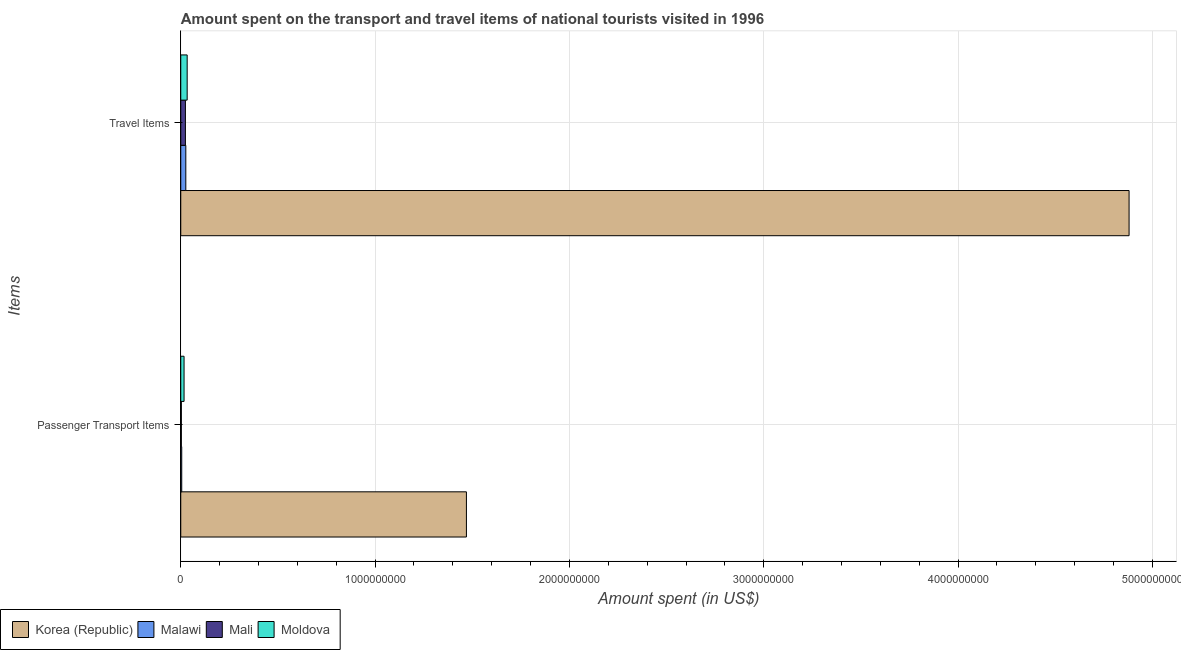How many different coloured bars are there?
Keep it short and to the point. 4. How many bars are there on the 2nd tick from the bottom?
Provide a succinct answer. 4. What is the label of the 1st group of bars from the top?
Provide a succinct answer. Travel Items. What is the amount spent in travel items in Mali?
Offer a terse response. 2.40e+07. Across all countries, what is the maximum amount spent on passenger transport items?
Give a very brief answer. 1.47e+09. Across all countries, what is the minimum amount spent on passenger transport items?
Your response must be concise. 3.00e+06. In which country was the amount spent on passenger transport items maximum?
Provide a succinct answer. Korea (Republic). In which country was the amount spent on passenger transport items minimum?
Ensure brevity in your answer.  Mali. What is the total amount spent on passenger transport items in the graph?
Keep it short and to the point. 1.50e+09. What is the difference between the amount spent on passenger transport items in Korea (Republic) and that in Moldova?
Your answer should be very brief. 1.45e+09. What is the difference between the amount spent in travel items in Mali and the amount spent on passenger transport items in Moldova?
Your answer should be compact. 7.00e+06. What is the average amount spent in travel items per country?
Give a very brief answer. 1.24e+09. What is the difference between the amount spent on passenger transport items and amount spent in travel items in Malawi?
Offer a very short reply. -2.10e+07. What is the ratio of the amount spent on passenger transport items in Moldova to that in Korea (Republic)?
Your answer should be compact. 0.01. What does the 3rd bar from the top in Travel Items represents?
Keep it short and to the point. Malawi. How many bars are there?
Provide a succinct answer. 8. Are all the bars in the graph horizontal?
Give a very brief answer. Yes. What is the difference between two consecutive major ticks on the X-axis?
Your response must be concise. 1.00e+09. Are the values on the major ticks of X-axis written in scientific E-notation?
Your response must be concise. No. Does the graph contain any zero values?
Give a very brief answer. No. Does the graph contain grids?
Ensure brevity in your answer.  Yes. How many legend labels are there?
Provide a short and direct response. 4. What is the title of the graph?
Your answer should be very brief. Amount spent on the transport and travel items of national tourists visited in 1996. What is the label or title of the X-axis?
Your response must be concise. Amount spent (in US$). What is the label or title of the Y-axis?
Your answer should be very brief. Items. What is the Amount spent (in US$) of Korea (Republic) in Passenger Transport Items?
Offer a very short reply. 1.47e+09. What is the Amount spent (in US$) of Malawi in Passenger Transport Items?
Provide a succinct answer. 5.00e+06. What is the Amount spent (in US$) of Moldova in Passenger Transport Items?
Provide a succinct answer. 1.70e+07. What is the Amount spent (in US$) in Korea (Republic) in Travel Items?
Keep it short and to the point. 4.88e+09. What is the Amount spent (in US$) of Malawi in Travel Items?
Make the answer very short. 2.60e+07. What is the Amount spent (in US$) of Mali in Travel Items?
Offer a very short reply. 2.40e+07. What is the Amount spent (in US$) in Moldova in Travel Items?
Your answer should be compact. 3.30e+07. Across all Items, what is the maximum Amount spent (in US$) of Korea (Republic)?
Offer a very short reply. 4.88e+09. Across all Items, what is the maximum Amount spent (in US$) in Malawi?
Offer a terse response. 2.60e+07. Across all Items, what is the maximum Amount spent (in US$) in Mali?
Keep it short and to the point. 2.40e+07. Across all Items, what is the maximum Amount spent (in US$) in Moldova?
Offer a terse response. 3.30e+07. Across all Items, what is the minimum Amount spent (in US$) in Korea (Republic)?
Keep it short and to the point. 1.47e+09. Across all Items, what is the minimum Amount spent (in US$) in Moldova?
Offer a terse response. 1.70e+07. What is the total Amount spent (in US$) in Korea (Republic) in the graph?
Your answer should be compact. 6.35e+09. What is the total Amount spent (in US$) of Malawi in the graph?
Give a very brief answer. 3.10e+07. What is the total Amount spent (in US$) of Mali in the graph?
Give a very brief answer. 2.70e+07. What is the total Amount spent (in US$) of Moldova in the graph?
Your answer should be compact. 5.00e+07. What is the difference between the Amount spent (in US$) of Korea (Republic) in Passenger Transport Items and that in Travel Items?
Your answer should be compact. -3.41e+09. What is the difference between the Amount spent (in US$) of Malawi in Passenger Transport Items and that in Travel Items?
Ensure brevity in your answer.  -2.10e+07. What is the difference between the Amount spent (in US$) in Mali in Passenger Transport Items and that in Travel Items?
Give a very brief answer. -2.10e+07. What is the difference between the Amount spent (in US$) of Moldova in Passenger Transport Items and that in Travel Items?
Offer a terse response. -1.60e+07. What is the difference between the Amount spent (in US$) in Korea (Republic) in Passenger Transport Items and the Amount spent (in US$) in Malawi in Travel Items?
Ensure brevity in your answer.  1.44e+09. What is the difference between the Amount spent (in US$) of Korea (Republic) in Passenger Transport Items and the Amount spent (in US$) of Mali in Travel Items?
Make the answer very short. 1.45e+09. What is the difference between the Amount spent (in US$) of Korea (Republic) in Passenger Transport Items and the Amount spent (in US$) of Moldova in Travel Items?
Make the answer very short. 1.44e+09. What is the difference between the Amount spent (in US$) of Malawi in Passenger Transport Items and the Amount spent (in US$) of Mali in Travel Items?
Your answer should be compact. -1.90e+07. What is the difference between the Amount spent (in US$) in Malawi in Passenger Transport Items and the Amount spent (in US$) in Moldova in Travel Items?
Give a very brief answer. -2.80e+07. What is the difference between the Amount spent (in US$) in Mali in Passenger Transport Items and the Amount spent (in US$) in Moldova in Travel Items?
Your response must be concise. -3.00e+07. What is the average Amount spent (in US$) in Korea (Republic) per Items?
Provide a short and direct response. 3.18e+09. What is the average Amount spent (in US$) in Malawi per Items?
Offer a very short reply. 1.55e+07. What is the average Amount spent (in US$) in Mali per Items?
Your response must be concise. 1.35e+07. What is the average Amount spent (in US$) of Moldova per Items?
Your response must be concise. 2.50e+07. What is the difference between the Amount spent (in US$) of Korea (Republic) and Amount spent (in US$) of Malawi in Passenger Transport Items?
Provide a short and direct response. 1.46e+09. What is the difference between the Amount spent (in US$) of Korea (Republic) and Amount spent (in US$) of Mali in Passenger Transport Items?
Make the answer very short. 1.47e+09. What is the difference between the Amount spent (in US$) of Korea (Republic) and Amount spent (in US$) of Moldova in Passenger Transport Items?
Offer a terse response. 1.45e+09. What is the difference between the Amount spent (in US$) of Malawi and Amount spent (in US$) of Moldova in Passenger Transport Items?
Ensure brevity in your answer.  -1.20e+07. What is the difference between the Amount spent (in US$) of Mali and Amount spent (in US$) of Moldova in Passenger Transport Items?
Your response must be concise. -1.40e+07. What is the difference between the Amount spent (in US$) in Korea (Republic) and Amount spent (in US$) in Malawi in Travel Items?
Give a very brief answer. 4.85e+09. What is the difference between the Amount spent (in US$) in Korea (Republic) and Amount spent (in US$) in Mali in Travel Items?
Give a very brief answer. 4.86e+09. What is the difference between the Amount spent (in US$) of Korea (Republic) and Amount spent (in US$) of Moldova in Travel Items?
Ensure brevity in your answer.  4.85e+09. What is the difference between the Amount spent (in US$) of Malawi and Amount spent (in US$) of Moldova in Travel Items?
Provide a succinct answer. -7.00e+06. What is the difference between the Amount spent (in US$) in Mali and Amount spent (in US$) in Moldova in Travel Items?
Provide a succinct answer. -9.00e+06. What is the ratio of the Amount spent (in US$) in Korea (Republic) in Passenger Transport Items to that in Travel Items?
Your response must be concise. 0.3. What is the ratio of the Amount spent (in US$) of Malawi in Passenger Transport Items to that in Travel Items?
Ensure brevity in your answer.  0.19. What is the ratio of the Amount spent (in US$) of Mali in Passenger Transport Items to that in Travel Items?
Provide a short and direct response. 0.12. What is the ratio of the Amount spent (in US$) of Moldova in Passenger Transport Items to that in Travel Items?
Ensure brevity in your answer.  0.52. What is the difference between the highest and the second highest Amount spent (in US$) in Korea (Republic)?
Your answer should be compact. 3.41e+09. What is the difference between the highest and the second highest Amount spent (in US$) of Malawi?
Provide a succinct answer. 2.10e+07. What is the difference between the highest and the second highest Amount spent (in US$) of Mali?
Your response must be concise. 2.10e+07. What is the difference between the highest and the second highest Amount spent (in US$) of Moldova?
Provide a succinct answer. 1.60e+07. What is the difference between the highest and the lowest Amount spent (in US$) of Korea (Republic)?
Provide a short and direct response. 3.41e+09. What is the difference between the highest and the lowest Amount spent (in US$) of Malawi?
Give a very brief answer. 2.10e+07. What is the difference between the highest and the lowest Amount spent (in US$) in Mali?
Offer a very short reply. 2.10e+07. What is the difference between the highest and the lowest Amount spent (in US$) in Moldova?
Your response must be concise. 1.60e+07. 